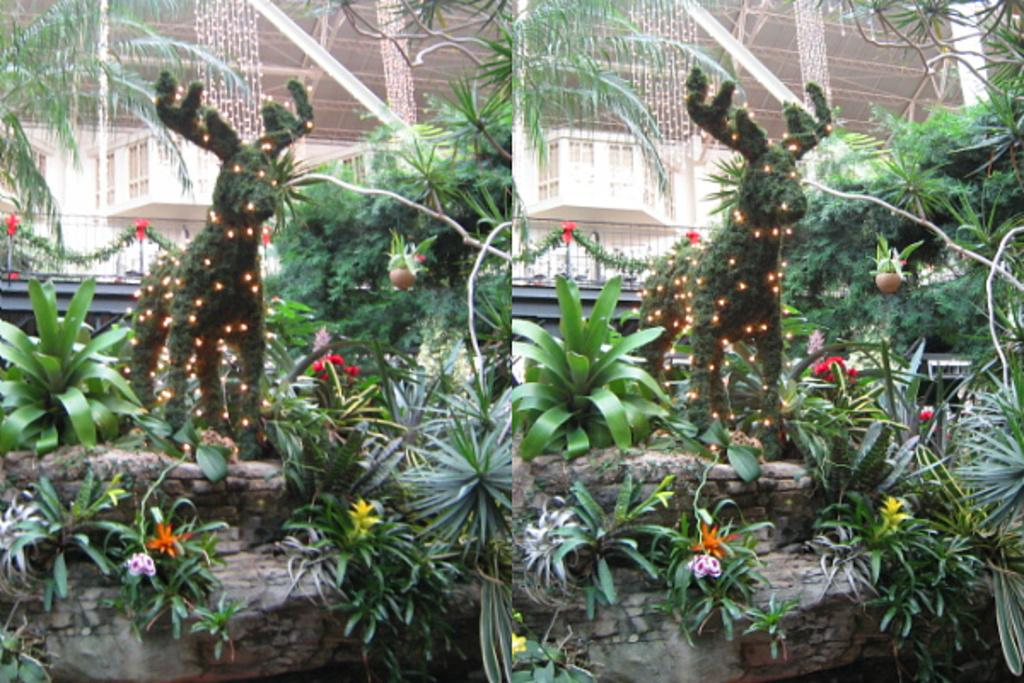What type of artwork is depicted in the image? The image is a collage. What types of vegetation are present in the image? There are plants, flowers, and trees in the image. What other objects can be seen in the image? There is a toy animal in the image. What can be seen in the background of the image? There is a building with lights in the background of the image. How many snakes are crawling on the toy animal in the image? There are no snakes present in the image; it only features a toy animal. What type of polish is being applied to the flowers in the image? There is no indication of any polish being applied to the flowers in the image; they appear to be natural. 